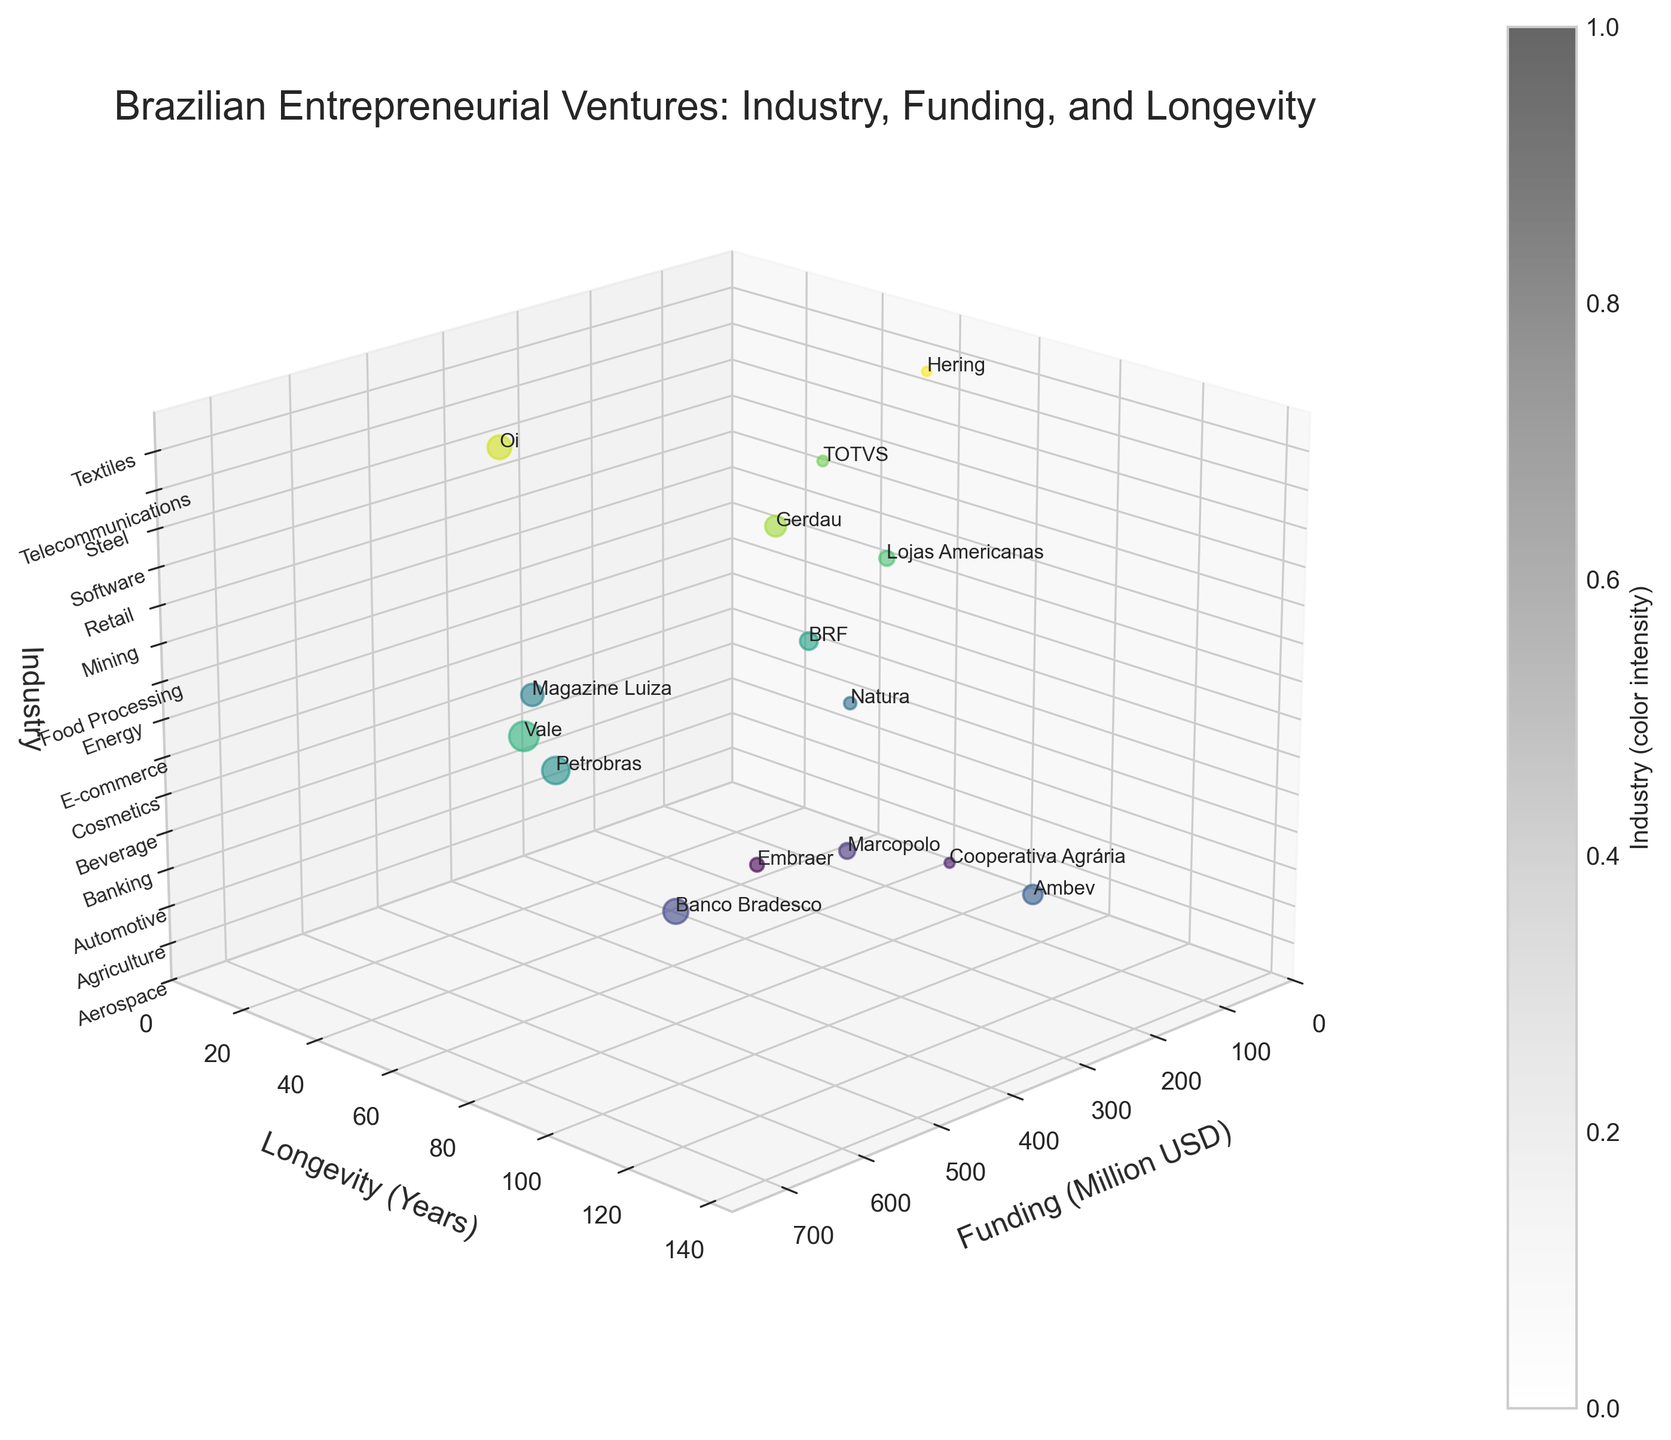what is the title of the plot? Look at the top of the plot where the title is usually located.
Answer: Brazilian Entrepreneurial Ventures: Industry, Funding, and Longevity how many industries are represented in the plot? Count the unique industry labels along the z-axis or the z-ticks.
Answer: 15 which company has the highest funding? Find the bubble with the highest value on the x-axis (Funding).
Answer: Vale how does the funding of Cooperativa Agrária compare to Hering? Look at the x-axis positions for both companies and compare their funding values.
Answer: Cooperativa Agrária has higher funding than Hering which industry has the longest average longevity among its companies? Identify the average longevity years for each industry by adding up the longevity values of companies within the same industry and then dividing by the number of companies in that industry.
Answer: Banking which company is both highly funded and has high longevity? Look for a company with both a large x (high funding) and large y (high longevity) value.
Answer: Banco Bradesco what is the range of funding among the companies shown in the plot? Determine the minimum and maximum values along the x-axis and find the range (max - min).
Answer: 70 to 700 Million USD how is the color coding used in the plot? Look at the color intensity explanation usually given by the color bar on the plot, and check how the colors vary among the data points.
Answer: The color intensity corresponds to industry category which industries are closest to having companies with equal longevity? Compare the y-axis values of companies within different industries and find those with nearly equal y-axis values.
Answer: Automotive and Food Processing how many companies have been in operation for over 50 years? Count the number of bubbles that lie beyond the 50-year mark on the y-axis.
Answer: 10 